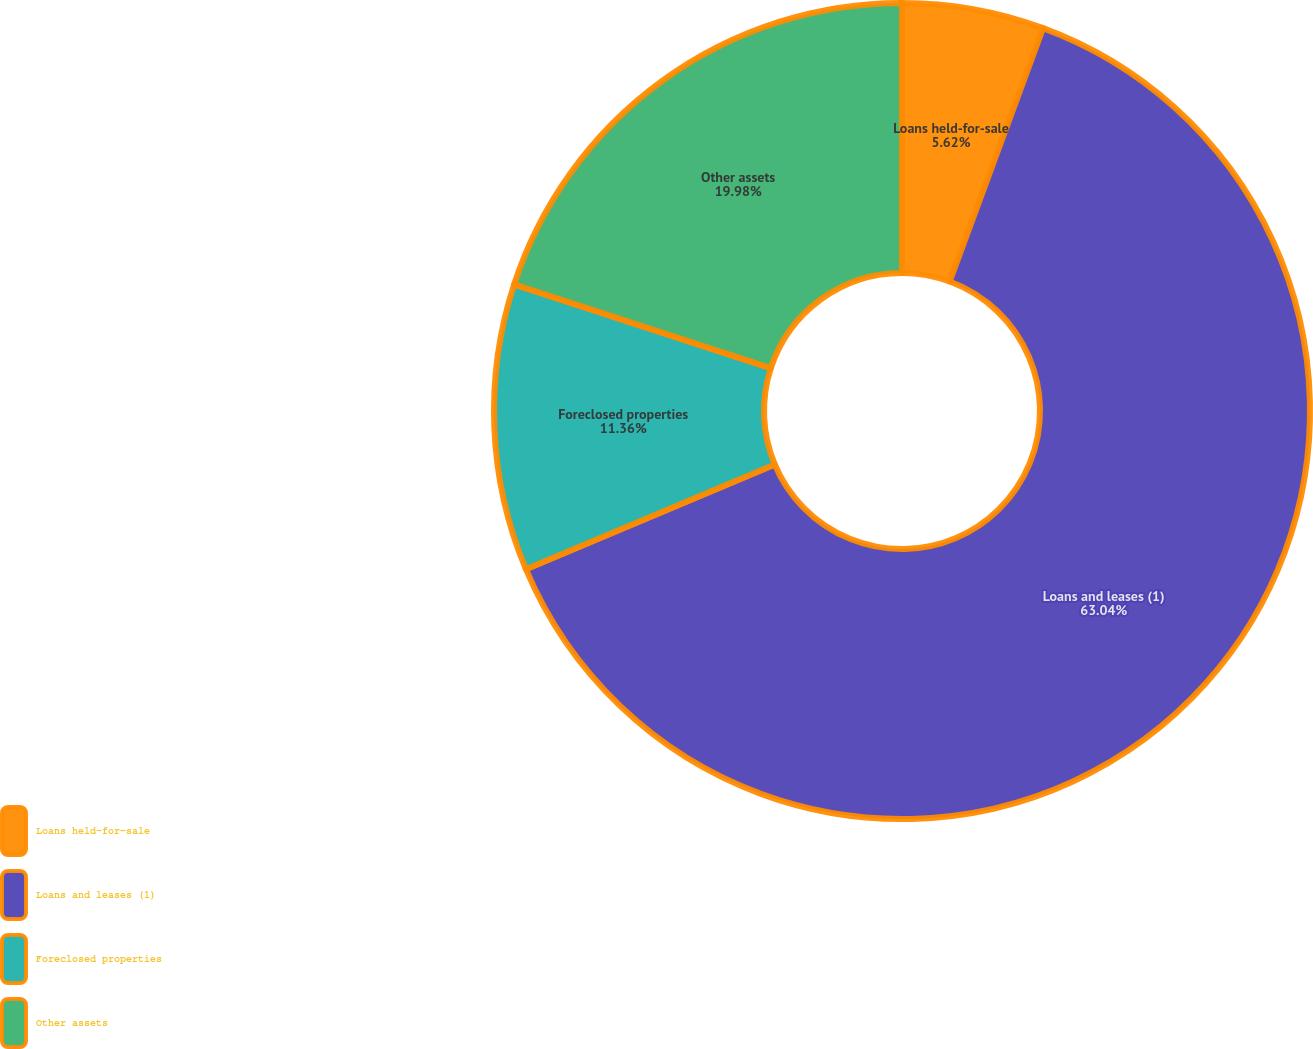Convert chart to OTSL. <chart><loc_0><loc_0><loc_500><loc_500><pie_chart><fcel>Loans held-for-sale<fcel>Loans and leases (1)<fcel>Foreclosed properties<fcel>Other assets<nl><fcel>5.62%<fcel>63.05%<fcel>11.36%<fcel>19.98%<nl></chart> 